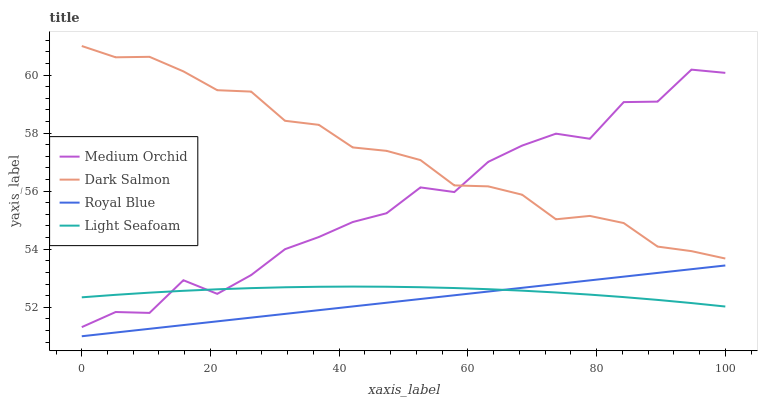Does Royal Blue have the minimum area under the curve?
Answer yes or no. Yes. Does Dark Salmon have the maximum area under the curve?
Answer yes or no. Yes. Does Medium Orchid have the minimum area under the curve?
Answer yes or no. No. Does Medium Orchid have the maximum area under the curve?
Answer yes or no. No. Is Royal Blue the smoothest?
Answer yes or no. Yes. Is Medium Orchid the roughest?
Answer yes or no. Yes. Is Dark Salmon the smoothest?
Answer yes or no. No. Is Dark Salmon the roughest?
Answer yes or no. No. Does Royal Blue have the lowest value?
Answer yes or no. Yes. Does Medium Orchid have the lowest value?
Answer yes or no. No. Does Dark Salmon have the highest value?
Answer yes or no. Yes. Does Medium Orchid have the highest value?
Answer yes or no. No. Is Light Seafoam less than Dark Salmon?
Answer yes or no. Yes. Is Dark Salmon greater than Light Seafoam?
Answer yes or no. Yes. Does Royal Blue intersect Light Seafoam?
Answer yes or no. Yes. Is Royal Blue less than Light Seafoam?
Answer yes or no. No. Is Royal Blue greater than Light Seafoam?
Answer yes or no. No. Does Light Seafoam intersect Dark Salmon?
Answer yes or no. No. 